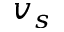Convert formula to latex. <formula><loc_0><loc_0><loc_500><loc_500>v _ { s }</formula> 